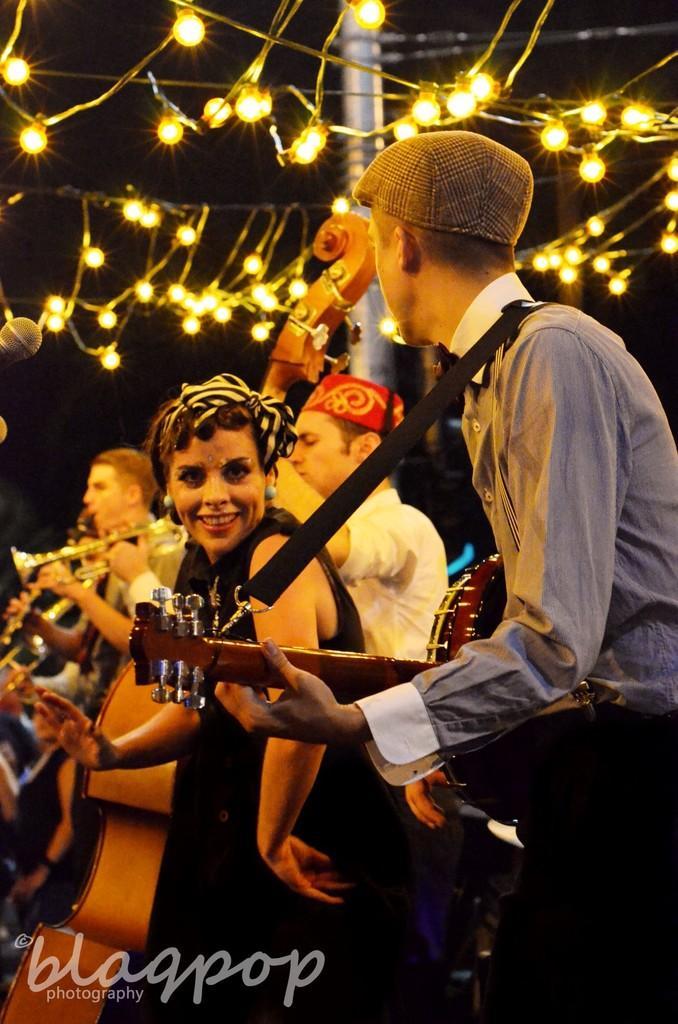Could you give a brief overview of what you see in this image? In this image in the right one person is playing guitar. He is wearing a blue shirt and a cap. Beside him a lady is dancing. And few more other people are playing some musical instruments. On the top there are lights. 